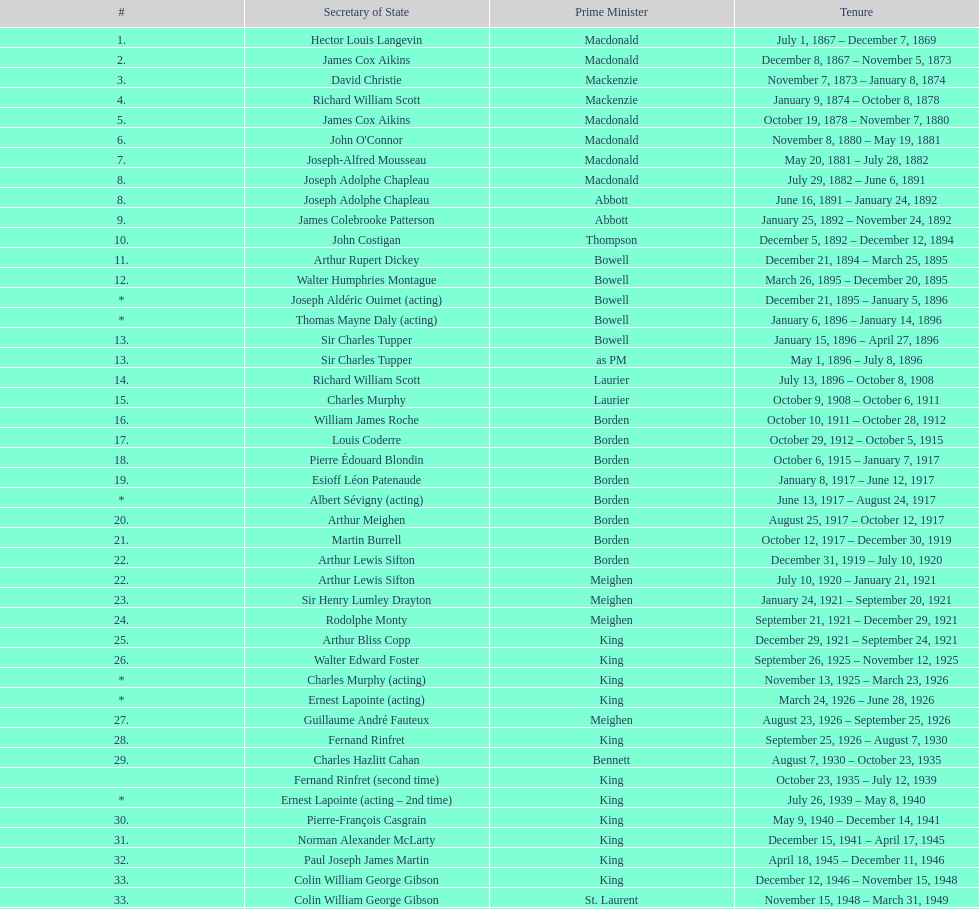How many secretaries of state had the last name bouchard? 2. 